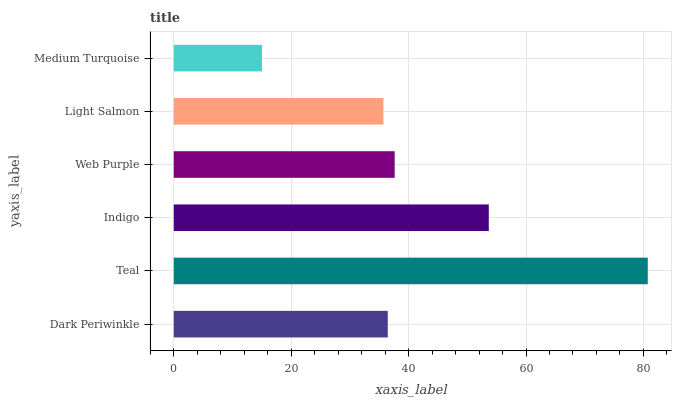Is Medium Turquoise the minimum?
Answer yes or no. Yes. Is Teal the maximum?
Answer yes or no. Yes. Is Indigo the minimum?
Answer yes or no. No. Is Indigo the maximum?
Answer yes or no. No. Is Teal greater than Indigo?
Answer yes or no. Yes. Is Indigo less than Teal?
Answer yes or no. Yes. Is Indigo greater than Teal?
Answer yes or no. No. Is Teal less than Indigo?
Answer yes or no. No. Is Web Purple the high median?
Answer yes or no. Yes. Is Dark Periwinkle the low median?
Answer yes or no. Yes. Is Teal the high median?
Answer yes or no. No. Is Medium Turquoise the low median?
Answer yes or no. No. 